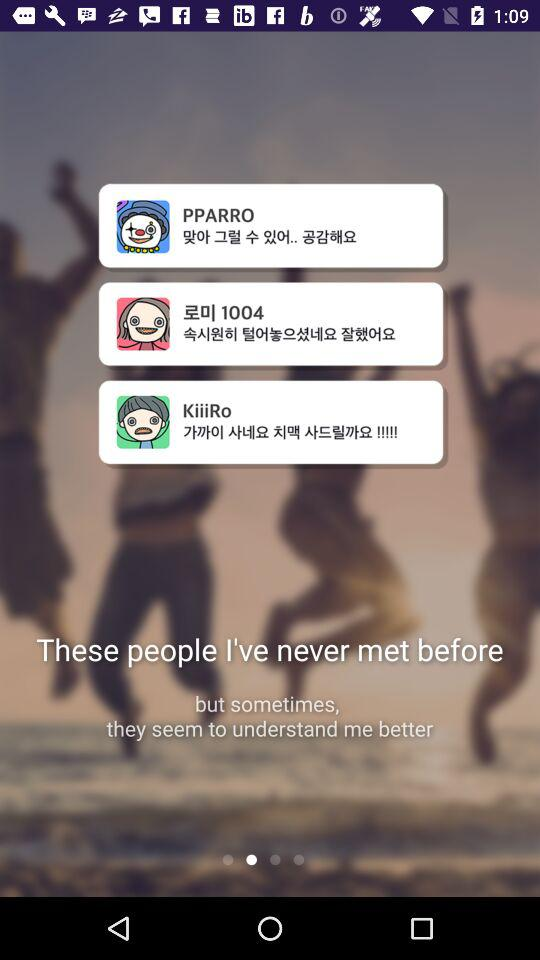How many people have I never met before?
Answer the question using a single word or phrase. 3 